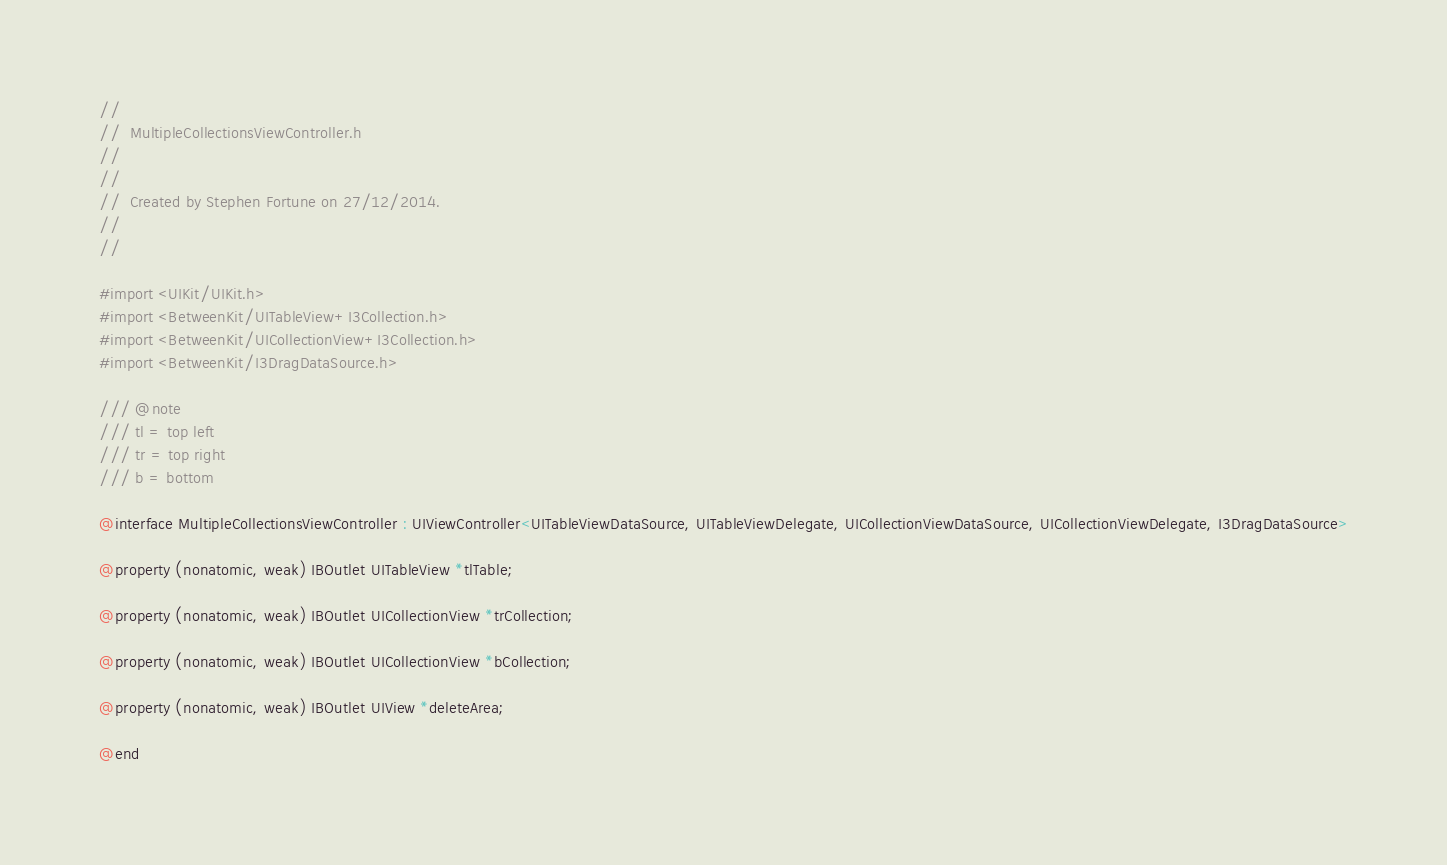Convert code to text. <code><loc_0><loc_0><loc_500><loc_500><_C_>//
//  MultipleCollectionsViewController.h
//  
//
//  Created by Stephen Fortune on 27/12/2014.
//
//

#import <UIKit/UIKit.h>
#import <BetweenKit/UITableView+I3Collection.h>
#import <BetweenKit/UICollectionView+I3Collection.h>
#import <BetweenKit/I3DragDataSource.h>

/// @note
/// tl = top left
/// tr = top right
/// b = bottom

@interface MultipleCollectionsViewController : UIViewController<UITableViewDataSource, UITableViewDelegate, UICollectionViewDataSource, UICollectionViewDelegate, I3DragDataSource>

@property (nonatomic, weak) IBOutlet UITableView *tlTable;

@property (nonatomic, weak) IBOutlet UICollectionView *trCollection;

@property (nonatomic, weak) IBOutlet UICollectionView *bCollection;

@property (nonatomic, weak) IBOutlet UIView *deleteArea;

@end
</code> 